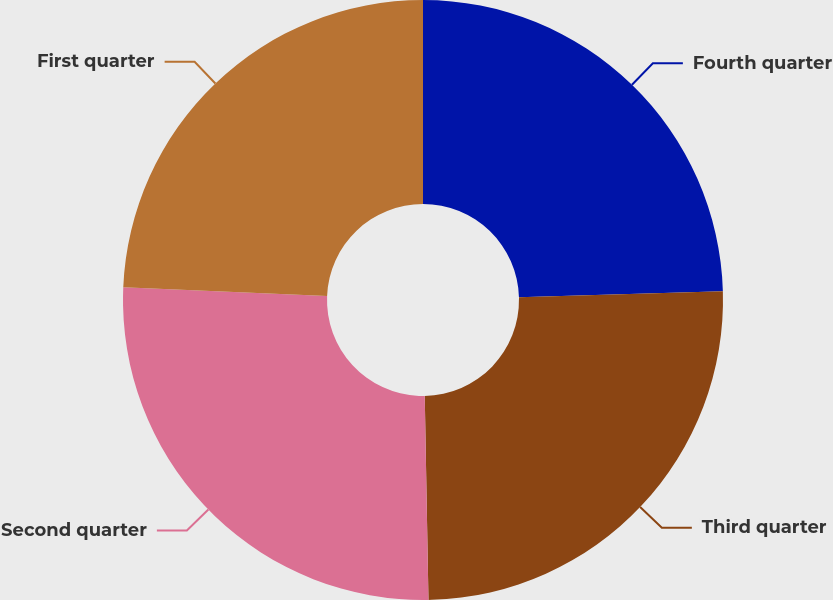Convert chart. <chart><loc_0><loc_0><loc_500><loc_500><pie_chart><fcel>Fourth quarter<fcel>Third quarter<fcel>Second quarter<fcel>First quarter<nl><fcel>24.53%<fcel>25.18%<fcel>25.96%<fcel>24.33%<nl></chart> 